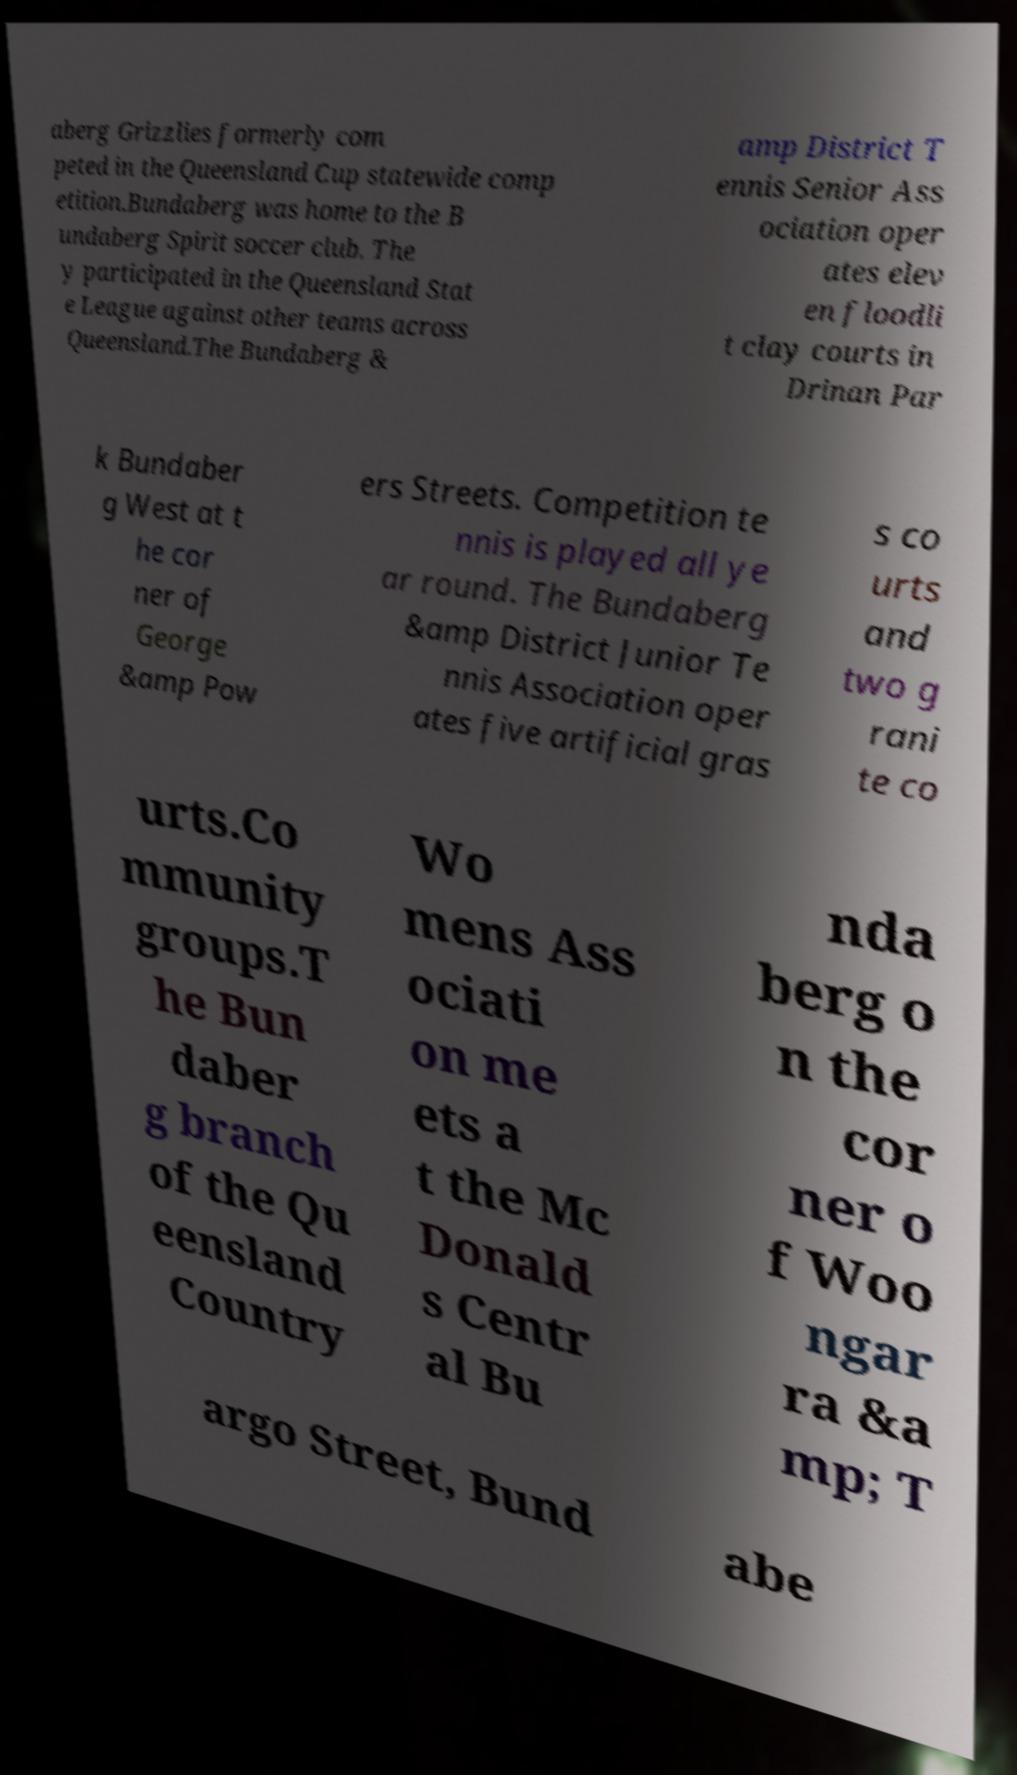Can you accurately transcribe the text from the provided image for me? aberg Grizzlies formerly com peted in the Queensland Cup statewide comp etition.Bundaberg was home to the B undaberg Spirit soccer club. The y participated in the Queensland Stat e League against other teams across Queensland.The Bundaberg & amp District T ennis Senior Ass ociation oper ates elev en floodli t clay courts in Drinan Par k Bundaber g West at t he cor ner of George &amp Pow ers Streets. Competition te nnis is played all ye ar round. The Bundaberg &amp District Junior Te nnis Association oper ates five artificial gras s co urts and two g rani te co urts.Co mmunity groups.T he Bun daber g branch of the Qu eensland Country Wo mens Ass ociati on me ets a t the Mc Donald s Centr al Bu nda berg o n the cor ner o f Woo ngar ra &a mp; T argo Street, Bund abe 